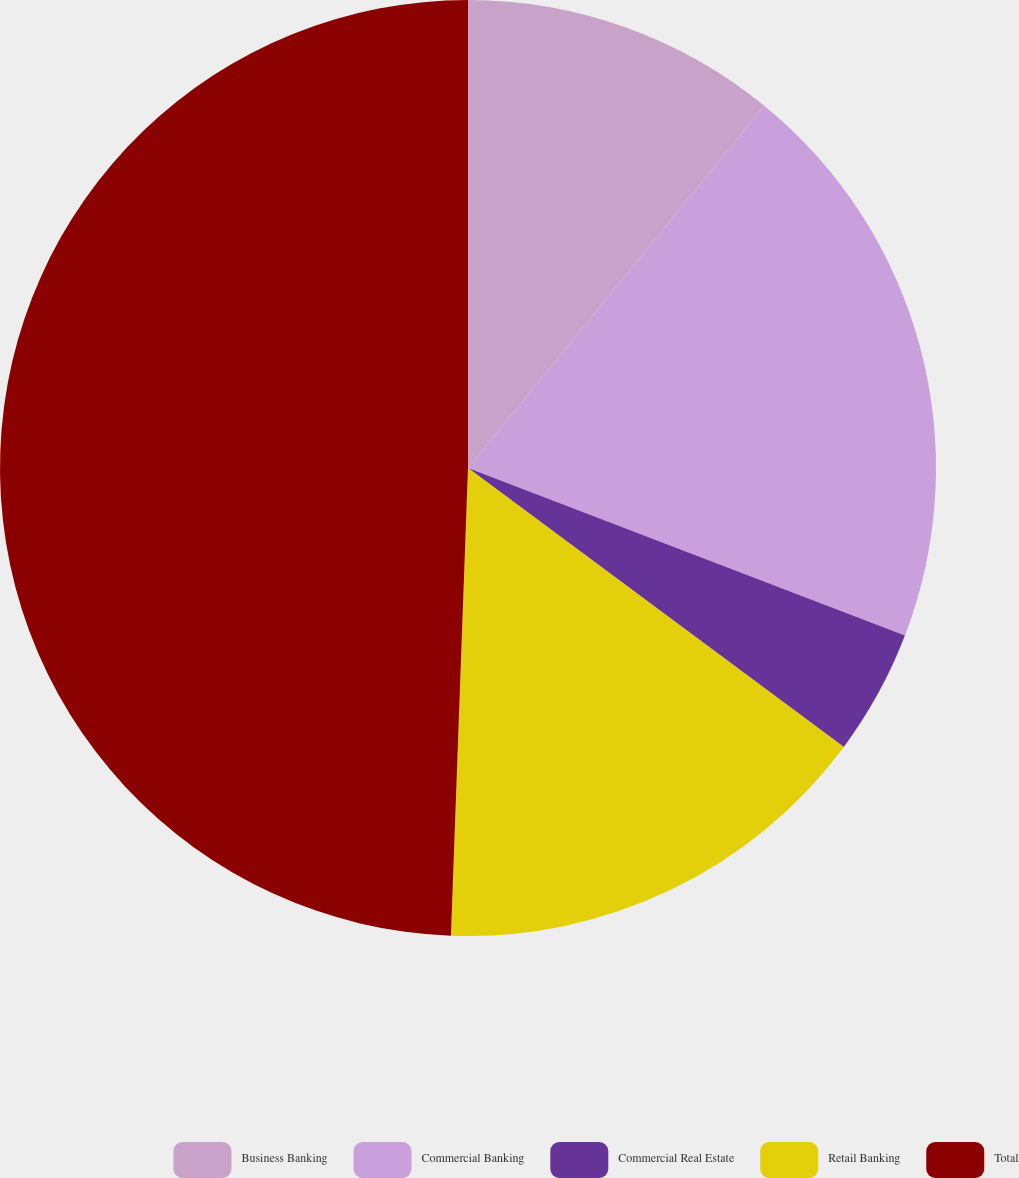Convert chart to OTSL. <chart><loc_0><loc_0><loc_500><loc_500><pie_chart><fcel>Business Banking<fcel>Commercial Banking<fcel>Commercial Real Estate<fcel>Retail Banking<fcel>Total<nl><fcel>10.91%<fcel>19.92%<fcel>4.33%<fcel>15.42%<fcel>49.42%<nl></chart> 